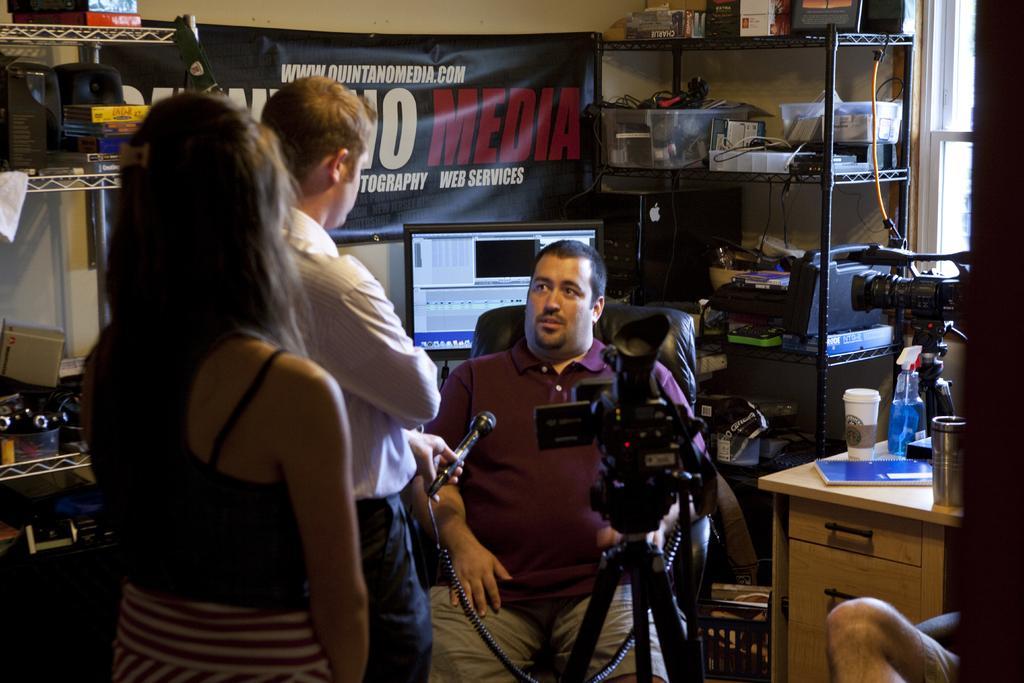In one or two sentences, can you explain what this image depicts? This picture describes about group of people, few are standing and a man is seated on the chair, in front of him we can see a camera and a microphone, behind him we can see a monitor, hoarding and few boxes in the racks, and we can see few bottles, cup, book and other things on the table. 